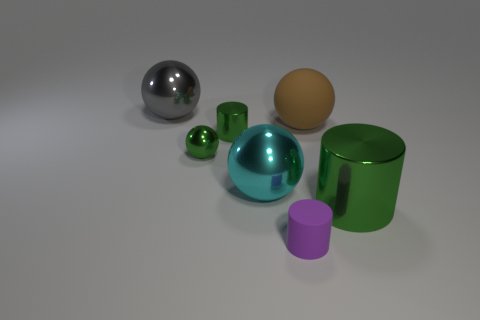Does the big shiny cylinder have the same color as the small sphere?
Offer a very short reply. Yes. There is a big shiny object that is the same color as the tiny metal cylinder; what shape is it?
Give a very brief answer. Cylinder. The green sphere that is the same material as the cyan object is what size?
Provide a short and direct response. Small. What number of big brown rubber objects are on the left side of the matte thing that is in front of the tiny green cylinder?
Offer a very short reply. 0. Are there any tiny green metal things that have the same shape as the gray object?
Offer a terse response. Yes. There is a large sphere that is to the left of the green metallic cylinder that is behind the cyan shiny ball; what color is it?
Your answer should be compact. Gray. Are there more gray metal objects than brown matte cylinders?
Ensure brevity in your answer.  Yes. What number of green cylinders have the same size as the brown rubber object?
Your answer should be very brief. 1. Is the brown thing made of the same material as the cylinder that is behind the large cylinder?
Provide a short and direct response. No. Is the number of cylinders less than the number of cyan things?
Give a very brief answer. No. 